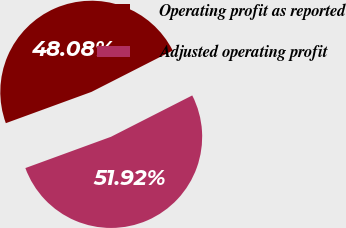Convert chart. <chart><loc_0><loc_0><loc_500><loc_500><pie_chart><fcel>Operating profit as reported<fcel>Adjusted operating profit<nl><fcel>48.08%<fcel>51.92%<nl></chart> 